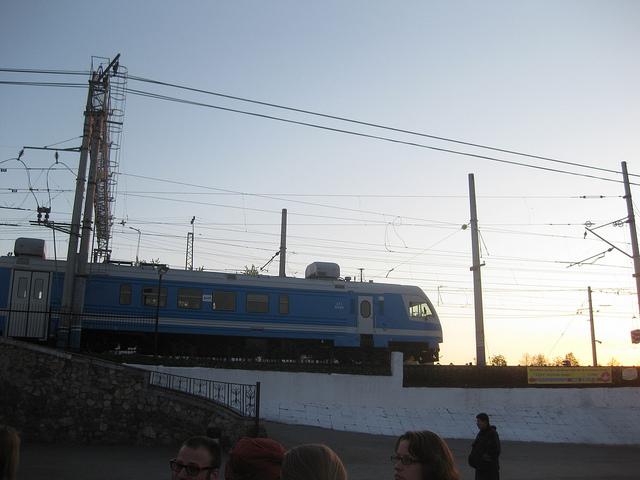How many people appear in this photo?
Give a very brief answer. 5. Are these people in a hurry to catch the train?
Answer briefly. No. What color is the train?
Give a very brief answer. Blue. 